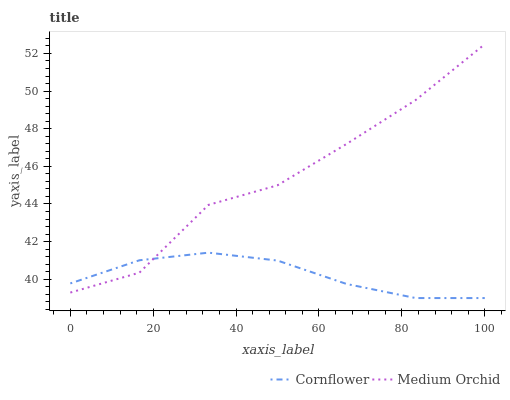Does Cornflower have the minimum area under the curve?
Answer yes or no. Yes. Does Medium Orchid have the maximum area under the curve?
Answer yes or no. Yes. Does Medium Orchid have the minimum area under the curve?
Answer yes or no. No. Is Cornflower the smoothest?
Answer yes or no. Yes. Is Medium Orchid the roughest?
Answer yes or no. Yes. Is Medium Orchid the smoothest?
Answer yes or no. No. Does Medium Orchid have the lowest value?
Answer yes or no. No. 